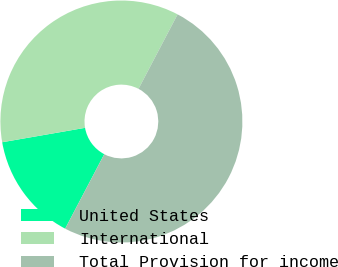Convert chart. <chart><loc_0><loc_0><loc_500><loc_500><pie_chart><fcel>United States<fcel>International<fcel>Total Provision for income<nl><fcel>14.57%<fcel>35.43%<fcel>50.0%<nl></chart> 